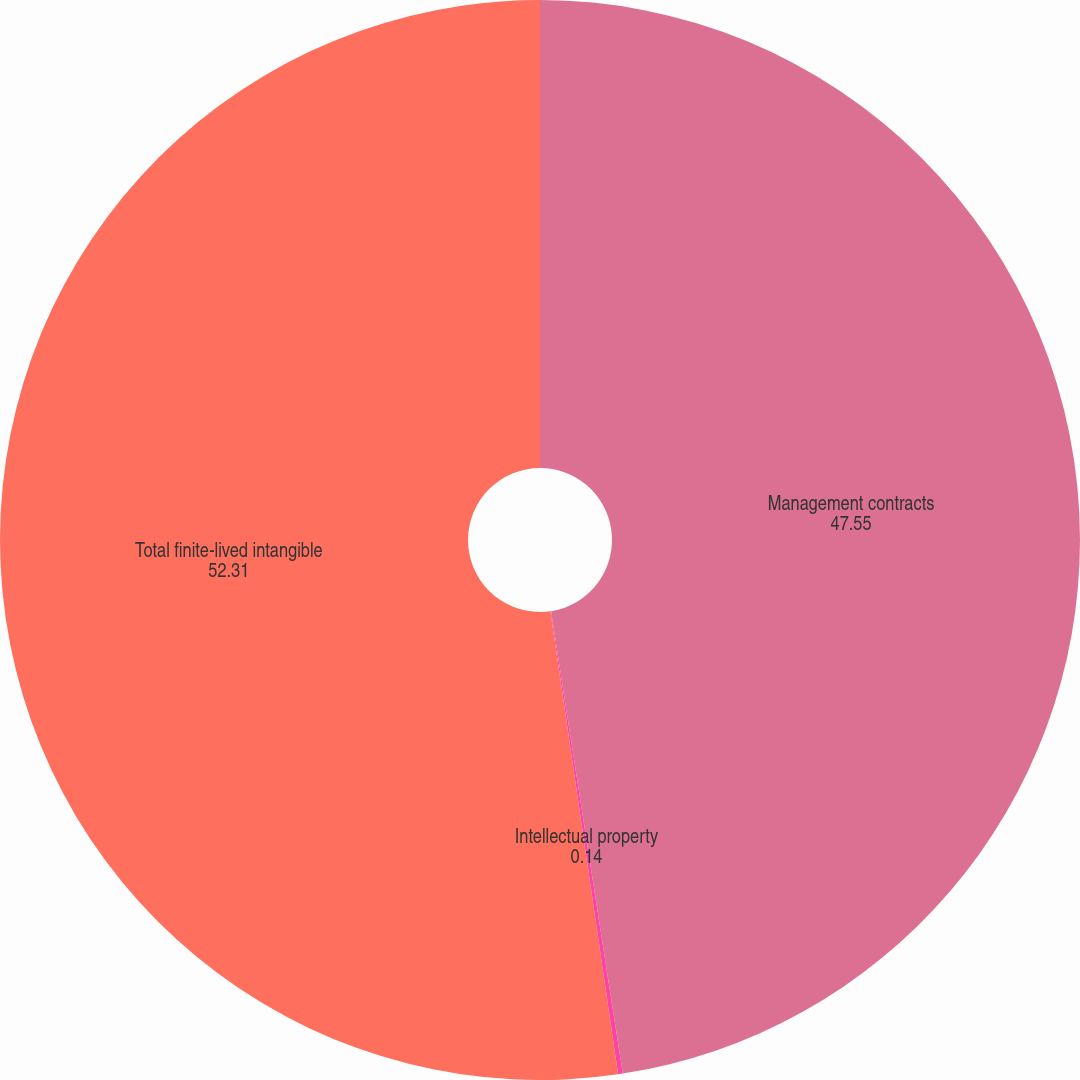Convert chart to OTSL. <chart><loc_0><loc_0><loc_500><loc_500><pie_chart><fcel>Management contracts<fcel>Intellectual property<fcel>Total finite-lived intangible<nl><fcel>47.55%<fcel>0.14%<fcel>52.31%<nl></chart> 